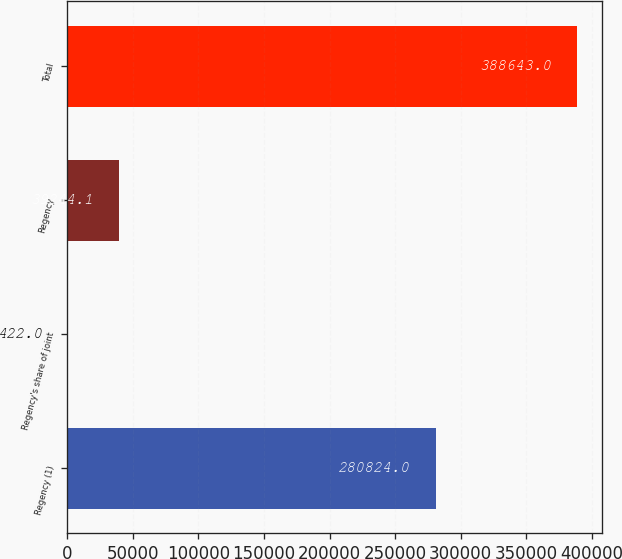Convert chart. <chart><loc_0><loc_0><loc_500><loc_500><bar_chart><fcel>Regency (1)<fcel>Regency's share of joint<fcel>Regency<fcel>Total<nl><fcel>280824<fcel>422<fcel>39244.1<fcel>388643<nl></chart> 